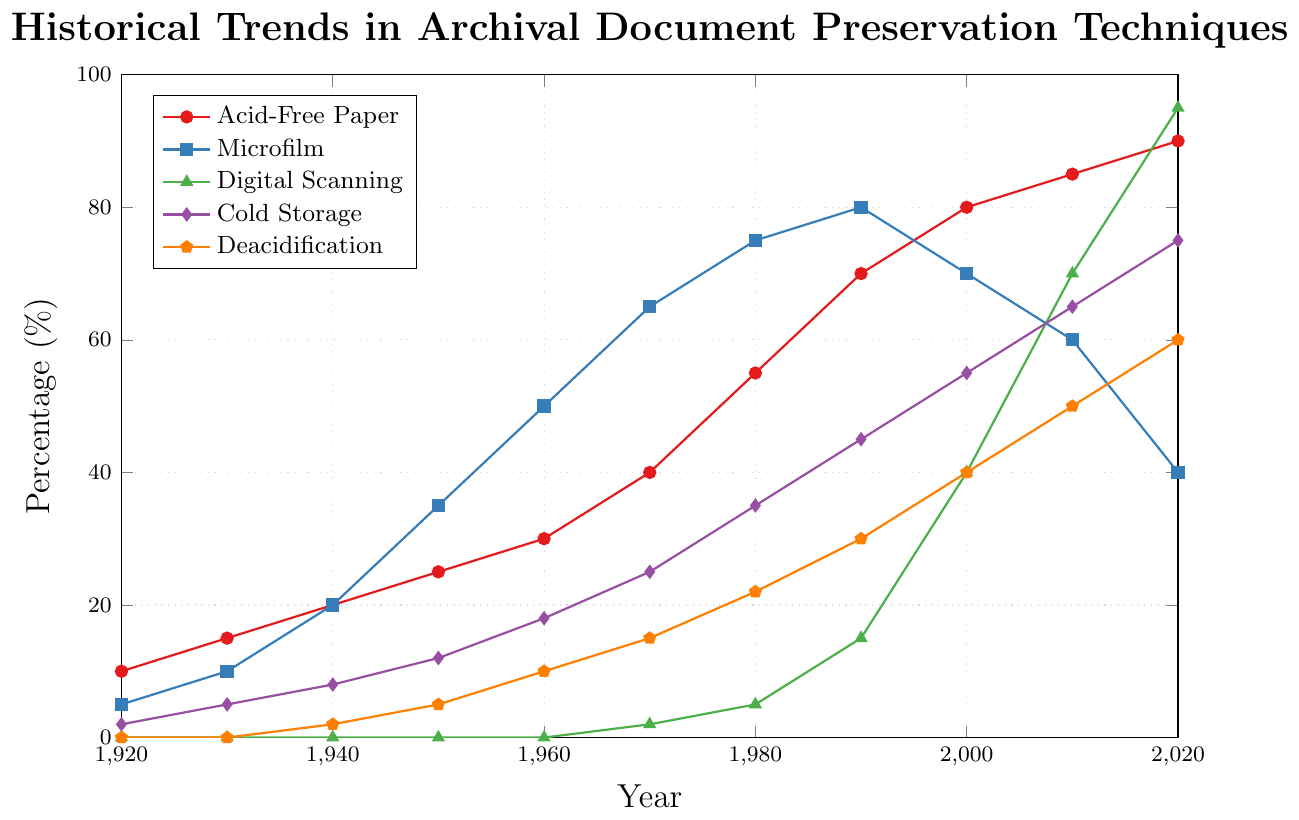What was the highest percentage of Microfilm used throughout the century? Observing the orange line labeled "Microfilm," the highest percentage corresponds to the year 1990, where it reaches its peak at 80%.
Answer: 80% Which preservation technique showed the most rapid growth between 2000 and 2020? The purple line represents "Digital Scanning." Between 2000 and 2020, the percentage increases from 40% to 95%, showing the most substantial growth compared to other techniques.
Answer: Digital Scanning How does the 2020 percentage of Acid-Free Paper compare to Cold Storage? In 2020, Acid-Free Paper is at 90%, while Cold Storage is at 75%.
Answer: Acid-Free Paper is 15% higher than Cold Storage Calculate the average percentage of Deacidification from 1920 to 2020. The percentages are 0, 0, 2, 5, 10, 15, 22, 30, 40, 50, and 60. Summing these gives 234; the average is 234 divided by 11 years, which is approximately 21.27%.
Answer: 21.27% Identify the year when Cold Storage and Acid-Free Paper percentages were equal. Checking the graph, they were never exactly equal, but in 1960, their percentages were closest, at 30% for Acid-Free Paper and 18% for Cold Storage.
Answer: Never exactly equal Which technique was consistently used the least? Referring to the lines, Digital Scanning starts later and grows slower compared to others until the late 2000s.
Answer: Digital Scanning initially What is the difference in the percentage of Microfilm usage between 1990 and 2020? Microfilm in 1990 is at 80%, and in 2020, it drops to 40%. The difference is 80% - 40% = 40%.
Answer: 40% Determine whether Cold Storage or Deacidification grew more steadily from 1920 to 2020. Both techniques grew, but Cold Storage shows a steadier increase compared to the more variable growth of Deacidification.
Answer: Cold Storage In which year did Digital Scanning surpass Microfilm in usage? Digital Scanning surpasses Microfilm around 2010.
Answer: Around 2010 What was the total percentage increase of Acid-Free Paper from 1940 to 2000? Acid-Free Paper in 1940 is 20%, and by 2000 it is 80%. The increase is 80% - 20% = 60%.
Answer: 60% 